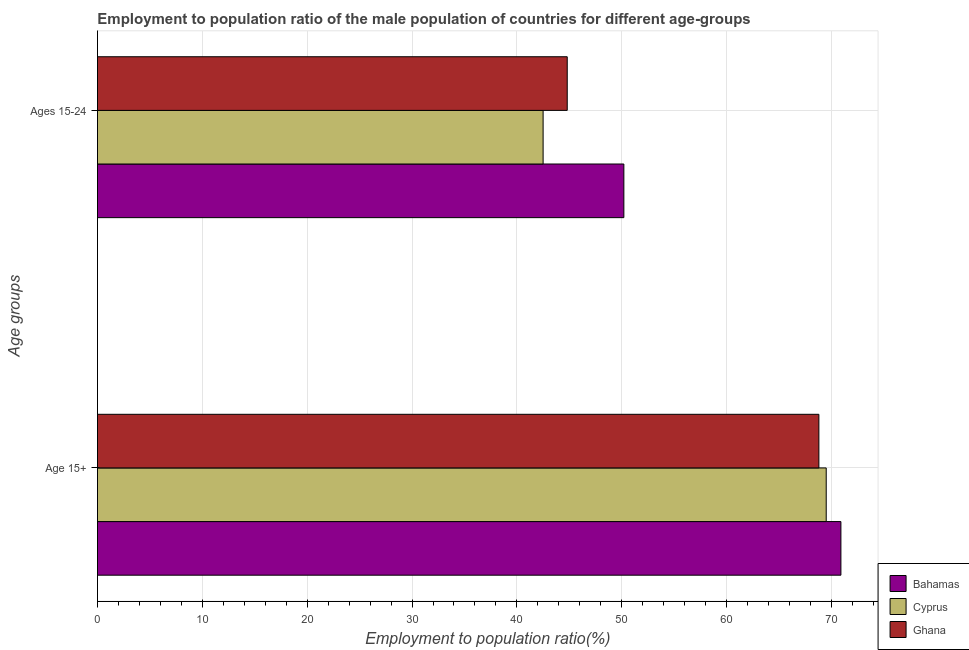How many different coloured bars are there?
Your answer should be very brief. 3. Are the number of bars on each tick of the Y-axis equal?
Offer a very short reply. Yes. What is the label of the 1st group of bars from the top?
Make the answer very short. Ages 15-24. What is the employment to population ratio(age 15+) in Cyprus?
Give a very brief answer. 69.5. Across all countries, what is the maximum employment to population ratio(age 15-24)?
Offer a terse response. 50.2. Across all countries, what is the minimum employment to population ratio(age 15+)?
Give a very brief answer. 68.8. In which country was the employment to population ratio(age 15+) maximum?
Your answer should be compact. Bahamas. In which country was the employment to population ratio(age 15-24) minimum?
Make the answer very short. Cyprus. What is the total employment to population ratio(age 15-24) in the graph?
Provide a succinct answer. 137.5. What is the difference between the employment to population ratio(age 15-24) in Cyprus and that in Ghana?
Your response must be concise. -2.3. What is the difference between the employment to population ratio(age 15+) in Ghana and the employment to population ratio(age 15-24) in Cyprus?
Provide a short and direct response. 26.3. What is the average employment to population ratio(age 15+) per country?
Your answer should be very brief. 69.73. What is the difference between the employment to population ratio(age 15+) and employment to population ratio(age 15-24) in Bahamas?
Give a very brief answer. 20.7. In how many countries, is the employment to population ratio(age 15+) greater than 66 %?
Provide a short and direct response. 3. What is the ratio of the employment to population ratio(age 15-24) in Bahamas to that in Ghana?
Your response must be concise. 1.12. What does the 2nd bar from the bottom in Ages 15-24 represents?
Make the answer very short. Cyprus. How many bars are there?
Your answer should be compact. 6. Are all the bars in the graph horizontal?
Ensure brevity in your answer.  Yes. What is the difference between two consecutive major ticks on the X-axis?
Keep it short and to the point. 10. Are the values on the major ticks of X-axis written in scientific E-notation?
Give a very brief answer. No. Does the graph contain any zero values?
Offer a very short reply. No. Where does the legend appear in the graph?
Provide a short and direct response. Bottom right. What is the title of the graph?
Your answer should be very brief. Employment to population ratio of the male population of countries for different age-groups. Does "Comoros" appear as one of the legend labels in the graph?
Provide a short and direct response. No. What is the label or title of the X-axis?
Keep it short and to the point. Employment to population ratio(%). What is the label or title of the Y-axis?
Ensure brevity in your answer.  Age groups. What is the Employment to population ratio(%) in Bahamas in Age 15+?
Ensure brevity in your answer.  70.9. What is the Employment to population ratio(%) in Cyprus in Age 15+?
Your response must be concise. 69.5. What is the Employment to population ratio(%) in Ghana in Age 15+?
Offer a terse response. 68.8. What is the Employment to population ratio(%) of Bahamas in Ages 15-24?
Offer a terse response. 50.2. What is the Employment to population ratio(%) of Cyprus in Ages 15-24?
Your answer should be very brief. 42.5. What is the Employment to population ratio(%) of Ghana in Ages 15-24?
Offer a very short reply. 44.8. Across all Age groups, what is the maximum Employment to population ratio(%) of Bahamas?
Provide a succinct answer. 70.9. Across all Age groups, what is the maximum Employment to population ratio(%) in Cyprus?
Ensure brevity in your answer.  69.5. Across all Age groups, what is the maximum Employment to population ratio(%) in Ghana?
Your answer should be very brief. 68.8. Across all Age groups, what is the minimum Employment to population ratio(%) of Bahamas?
Offer a very short reply. 50.2. Across all Age groups, what is the minimum Employment to population ratio(%) of Cyprus?
Your response must be concise. 42.5. Across all Age groups, what is the minimum Employment to population ratio(%) of Ghana?
Provide a succinct answer. 44.8. What is the total Employment to population ratio(%) of Bahamas in the graph?
Keep it short and to the point. 121.1. What is the total Employment to population ratio(%) in Cyprus in the graph?
Provide a short and direct response. 112. What is the total Employment to population ratio(%) in Ghana in the graph?
Make the answer very short. 113.6. What is the difference between the Employment to population ratio(%) in Bahamas in Age 15+ and that in Ages 15-24?
Offer a terse response. 20.7. What is the difference between the Employment to population ratio(%) in Cyprus in Age 15+ and that in Ages 15-24?
Keep it short and to the point. 27. What is the difference between the Employment to population ratio(%) of Bahamas in Age 15+ and the Employment to population ratio(%) of Cyprus in Ages 15-24?
Offer a terse response. 28.4. What is the difference between the Employment to population ratio(%) in Bahamas in Age 15+ and the Employment to population ratio(%) in Ghana in Ages 15-24?
Provide a short and direct response. 26.1. What is the difference between the Employment to population ratio(%) of Cyprus in Age 15+ and the Employment to population ratio(%) of Ghana in Ages 15-24?
Provide a succinct answer. 24.7. What is the average Employment to population ratio(%) of Bahamas per Age groups?
Provide a succinct answer. 60.55. What is the average Employment to population ratio(%) in Cyprus per Age groups?
Offer a very short reply. 56. What is the average Employment to population ratio(%) in Ghana per Age groups?
Offer a terse response. 56.8. What is the difference between the Employment to population ratio(%) of Bahamas and Employment to population ratio(%) of Ghana in Age 15+?
Your response must be concise. 2.1. What is the difference between the Employment to population ratio(%) in Cyprus and Employment to population ratio(%) in Ghana in Age 15+?
Provide a succinct answer. 0.7. What is the difference between the Employment to population ratio(%) of Bahamas and Employment to population ratio(%) of Cyprus in Ages 15-24?
Your answer should be very brief. 7.7. What is the difference between the Employment to population ratio(%) of Bahamas and Employment to population ratio(%) of Ghana in Ages 15-24?
Provide a short and direct response. 5.4. What is the ratio of the Employment to population ratio(%) of Bahamas in Age 15+ to that in Ages 15-24?
Your answer should be compact. 1.41. What is the ratio of the Employment to population ratio(%) in Cyprus in Age 15+ to that in Ages 15-24?
Make the answer very short. 1.64. What is the ratio of the Employment to population ratio(%) in Ghana in Age 15+ to that in Ages 15-24?
Give a very brief answer. 1.54. What is the difference between the highest and the second highest Employment to population ratio(%) of Bahamas?
Offer a terse response. 20.7. What is the difference between the highest and the second highest Employment to population ratio(%) in Cyprus?
Provide a succinct answer. 27. What is the difference between the highest and the second highest Employment to population ratio(%) of Ghana?
Provide a short and direct response. 24. What is the difference between the highest and the lowest Employment to population ratio(%) of Bahamas?
Your answer should be compact. 20.7. What is the difference between the highest and the lowest Employment to population ratio(%) of Ghana?
Provide a succinct answer. 24. 